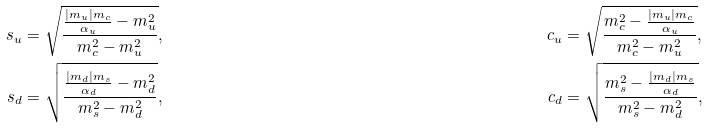<formula> <loc_0><loc_0><loc_500><loc_500>s _ { u } & = \sqrt { \frac { \frac { | m _ { u } | m _ { c } } { \alpha _ { u } } - m _ { u } ^ { 2 } } { m _ { c } ^ { 2 } - m _ { u } ^ { 2 } } } , & c _ { u } & = \sqrt { \frac { m _ { c } ^ { 2 } - \frac { | m _ { u } | m _ { c } } { \alpha _ { u } } } { m _ { c } ^ { 2 } - m _ { u } ^ { 2 } } } , \\ s _ { d } & = \sqrt { \frac { \frac { | m _ { d } | m _ { s } } { \alpha _ { d } } - m _ { d } ^ { 2 } } { m _ { s } ^ { 2 } - m _ { d } ^ { 2 } } } , & c _ { d } & = \sqrt { \frac { m _ { s } ^ { 2 } - \frac { | m _ { d } | m _ { s } } { \alpha _ { d } } } { m _ { s } ^ { 2 } - m _ { d } ^ { 2 } } } ,</formula> 